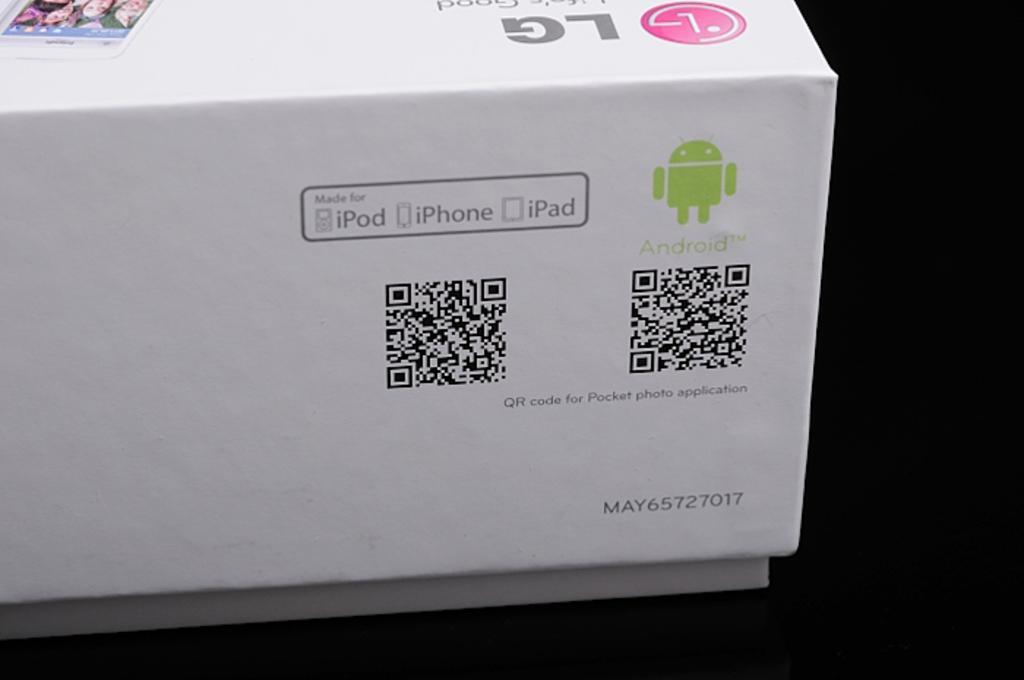<image>
Write a terse but informative summary of the picture. The box of an LG product made for iPod, iPhone, and iPad devices. 